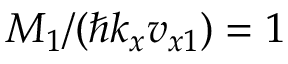<formula> <loc_0><loc_0><loc_500><loc_500>M _ { 1 } / ( \hbar { k } _ { x } v _ { x 1 } ) = 1</formula> 